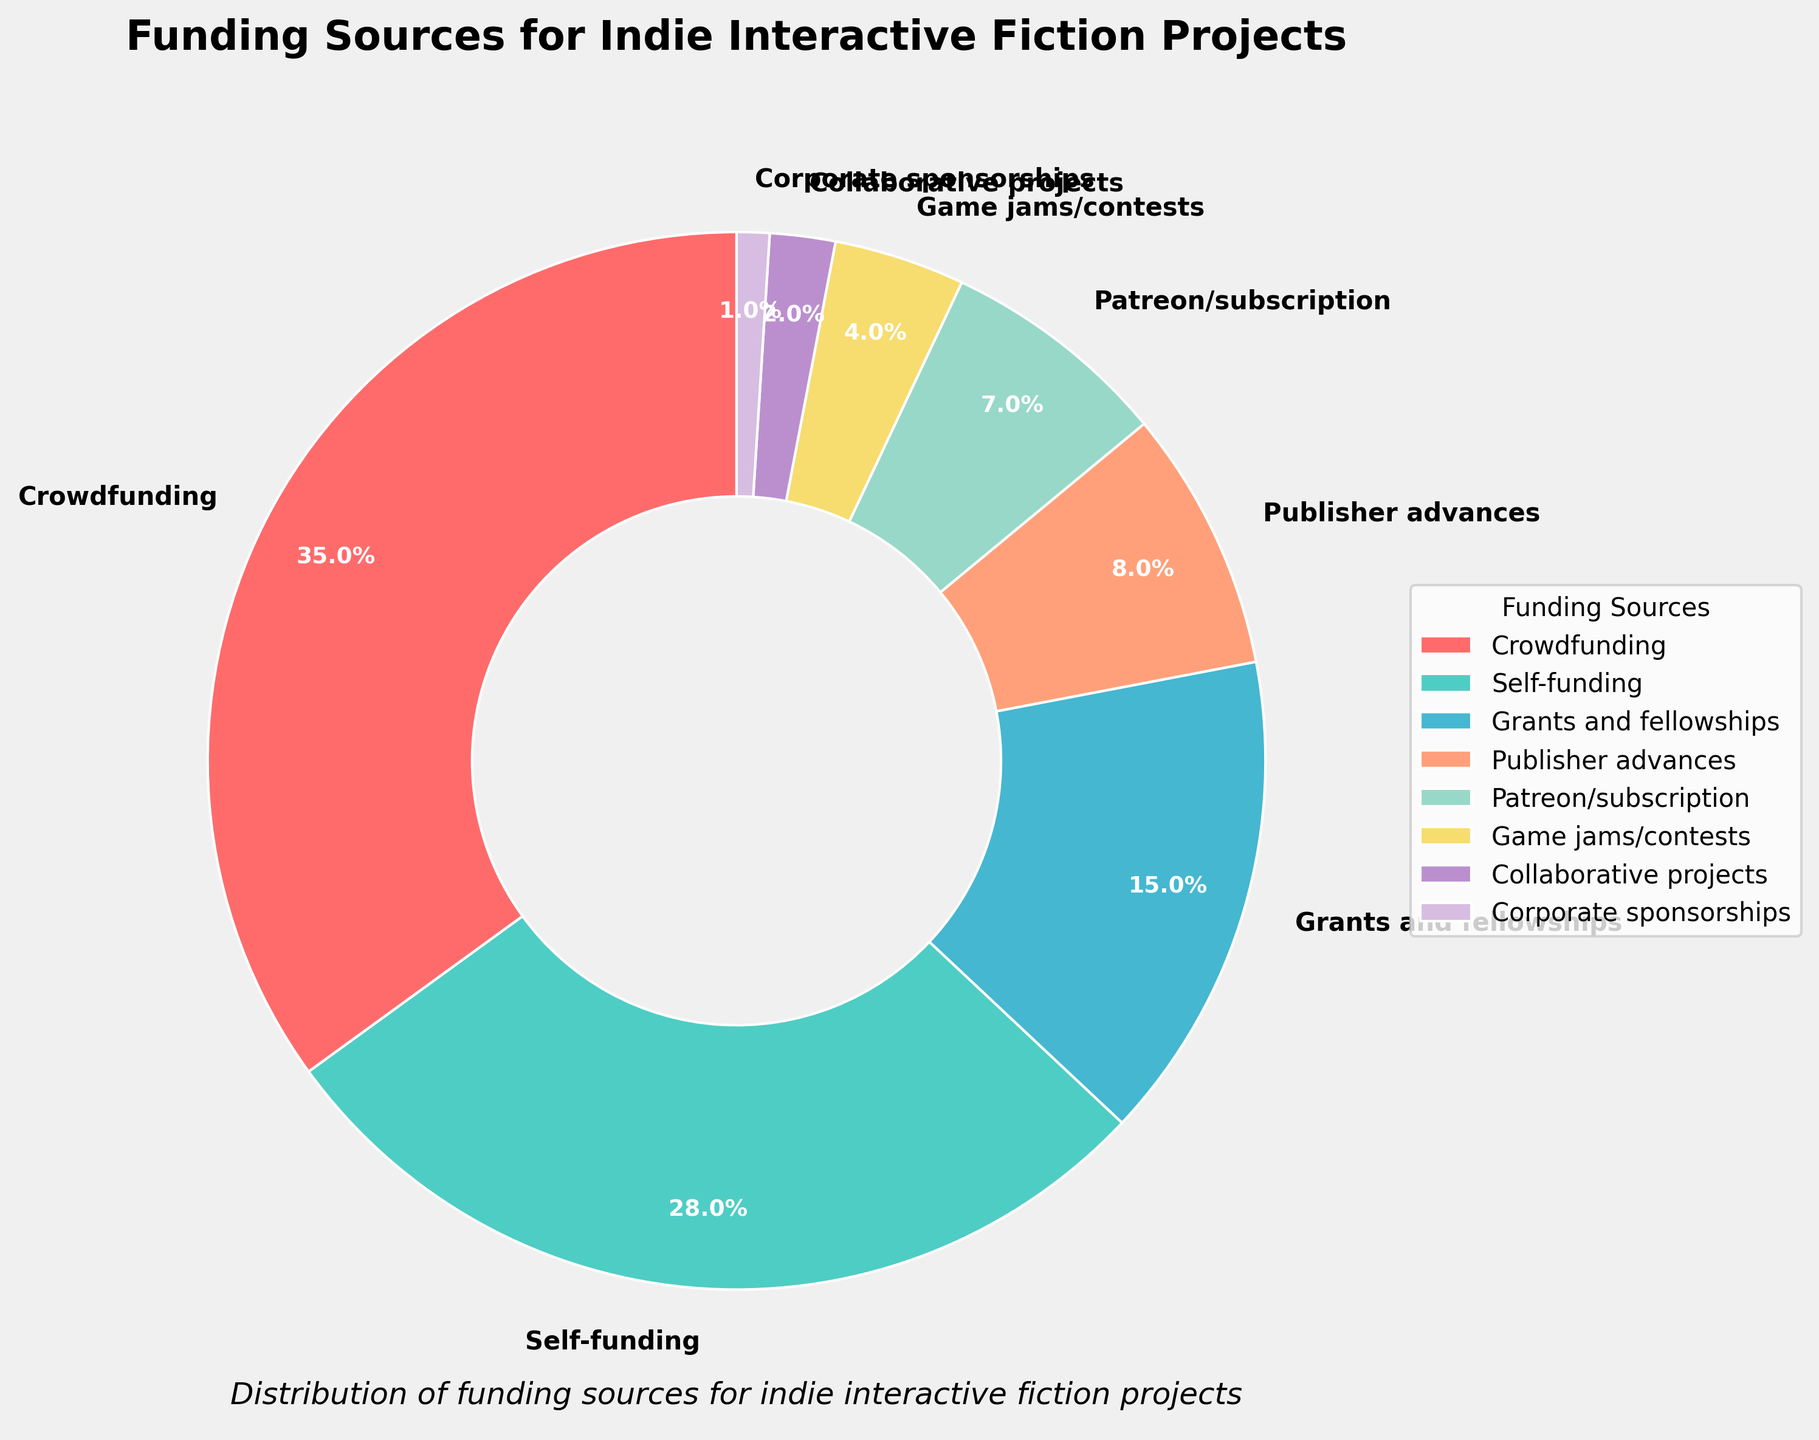What's the largest funding source for indie interactive fiction projects? By examining the figure, we can see that "Crowdfunding" occupies the largest section of the pie chart.
Answer: Crowdfunding How much more percentage does Crowdfunding contribute compared to Game jams/contests? Crowdfunding contributes 35%. Game jams/contests contribute 4%. Subtracting these gives 35% - 4% = 31%.
Answer: 31% Which funding sources contribute more than 25% combined? We need to add the percentages of the top contributors and see which sums exceed 25%. Crowdfunding (35%) alone already exceeds 25%.
Answer: Crowdfunding What is the total percentage contribution from Publisher advances, Patreon/subscription, and Game jams/contests? Adding the percentages of these three categories: Publisher advances (8%) + Patreon/subscription (7%) + Game jams/contests (4%) = 19%.
Answer: 19% Which category makes the smallest contribution to funding? The smallest portion of the pie chart is labeled "Corporate sponsorships," which contributes 1%.
Answer: Corporate sponsorships How much less does Self-funding contribute compared to Crowdfunding? Self-funding contributes 28% while Crowdfunding contributes 35%. Subtracting these gives 35% - 28% = 7%.
Answer: 7% How many categories contribute less than 10% each? By examining each segment, we see that Publisher advances (8%), Patreon/subscription (7%), Game jams/contests (4%), Collaborative projects (2%), and Corporate sponsorships (1%) all contribute less than 10%. Counting these gives five categories.
Answer: Five What is the combined percentage contribution of Self-funding and Grants and fellowships? Adding the percentages of Self-funding (28%) and Grants and fellowships (15%) gives 28% + 15% = 43%.
Answer: 43% Compare the contribution of Patreon/subscription to Corporate sponsorships. How many times larger is it? Patreon/subscription contributes 7% and Corporate sponsorships contribute 1%. Dividing these gives 7 / 1 = 7.
Answer: Seven Which funding sources combined contribute exactly 50%? By adding the percentages of various contributions in increasing order: Self-funding (28%) + Grants and fellowships (15%) + Publisher advances (8%) = 51%, Overshoot. Patreon/subscription (7%) + Game jams/contests (4%) + Collaborative projects (2%) + Corporate sponsorships (1%) = 14%, too small. Crowdfunding (35%) + Grants and fellowships (15%) = 50%.
Answer: Crowdfunding and Grants and fellowships 